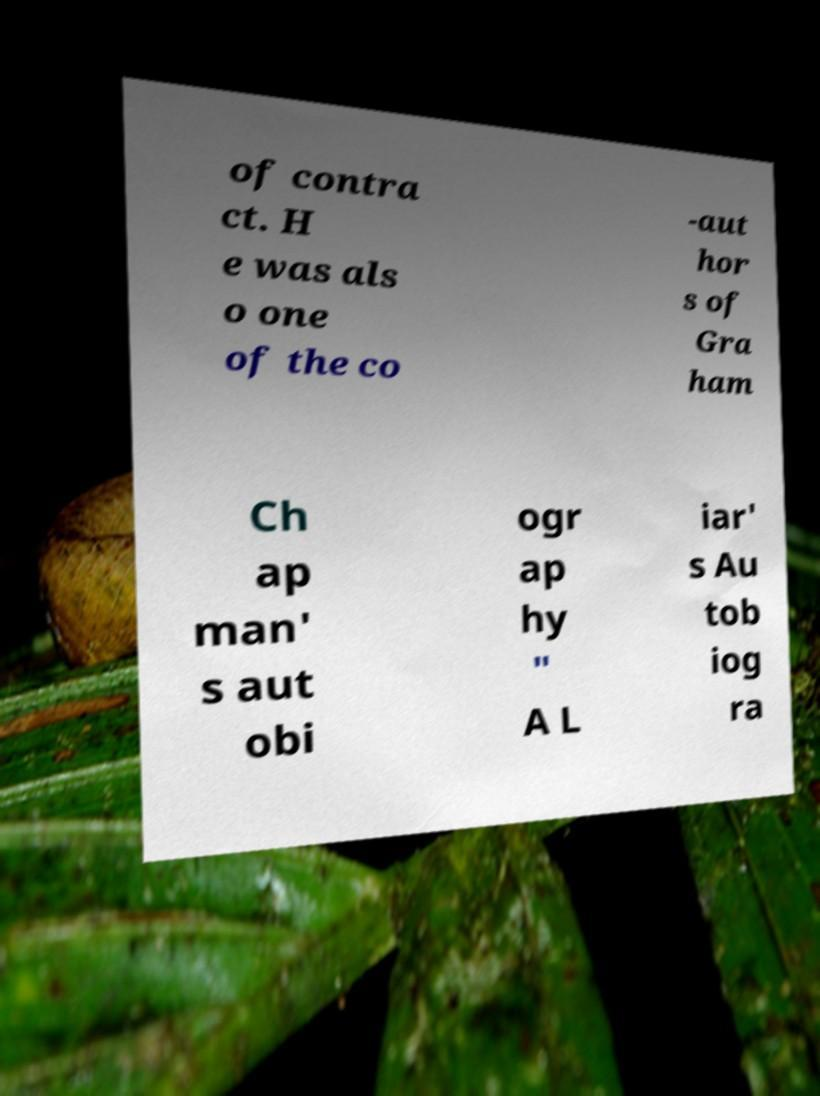There's text embedded in this image that I need extracted. Can you transcribe it verbatim? of contra ct. H e was als o one of the co -aut hor s of Gra ham Ch ap man' s aut obi ogr ap hy " A L iar' s Au tob iog ra 